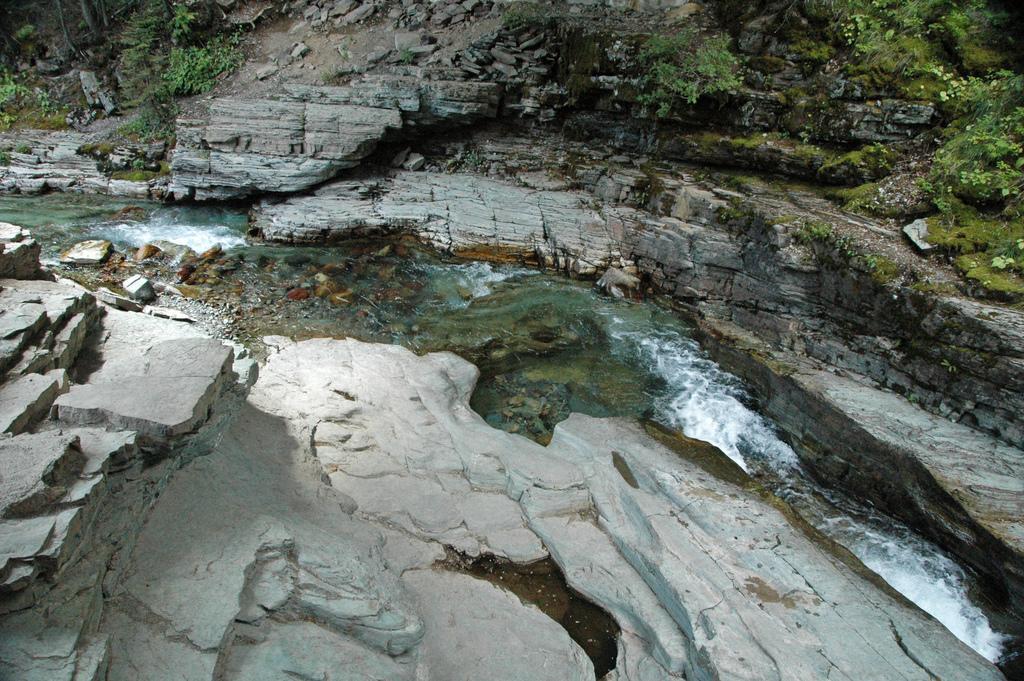Please provide a concise description of this image. In the image there is canal in the middle with huge rocks on either side of it with plants and algae over it. 